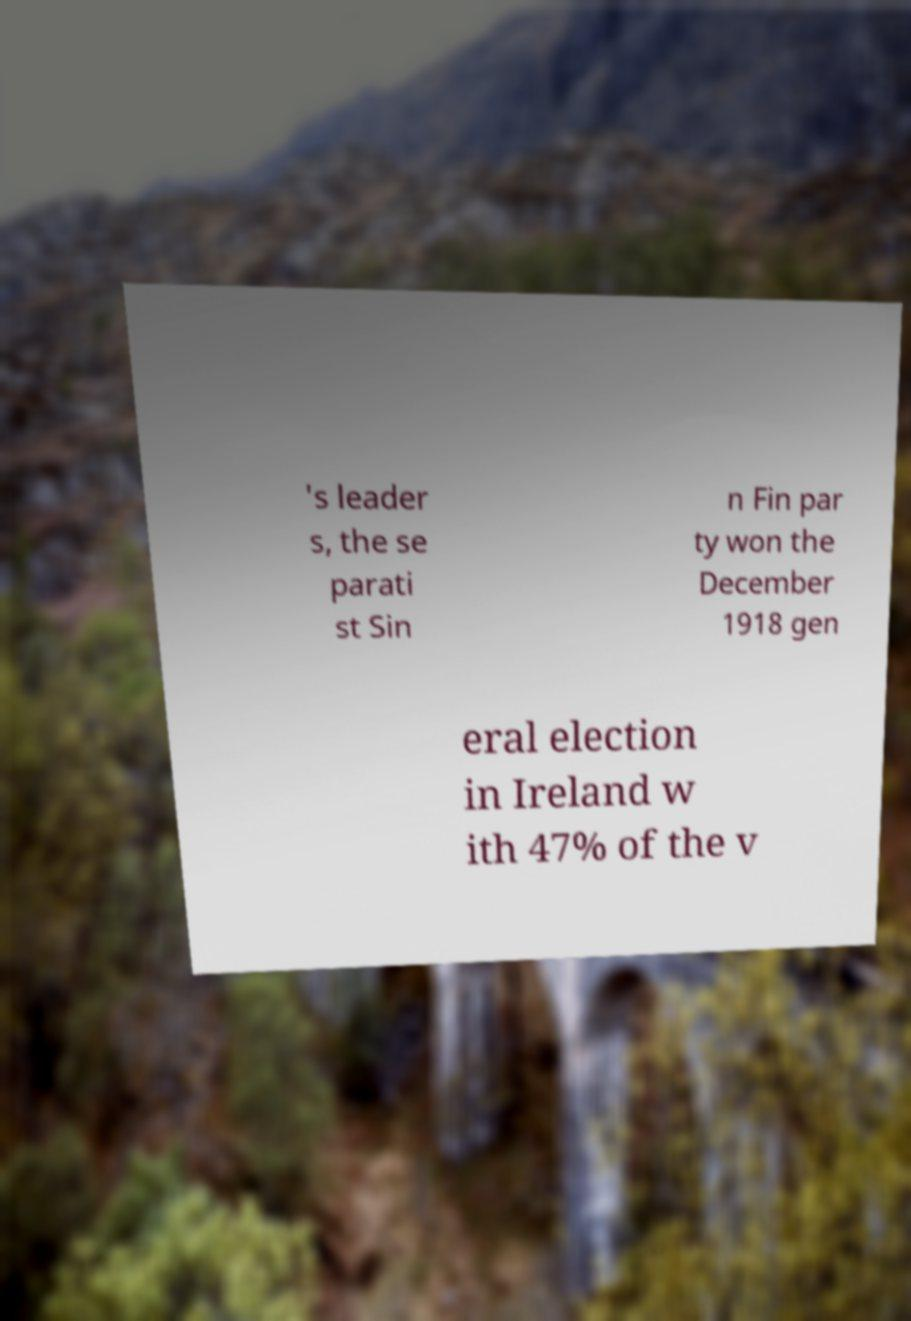Could you assist in decoding the text presented in this image and type it out clearly? 's leader s, the se parati st Sin n Fin par ty won the December 1918 gen eral election in Ireland w ith 47% of the v 